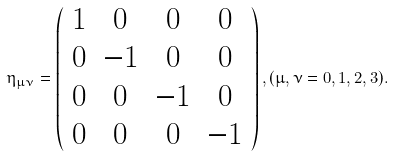Convert formula to latex. <formula><loc_0><loc_0><loc_500><loc_500>\eta _ { \mu \nu } = \left ( \begin{array} { c c c c } 1 & 0 & 0 & 0 \\ 0 & - 1 & 0 & 0 \\ 0 & 0 & - 1 & 0 \\ 0 & 0 & 0 & - 1 \end{array} \right ) , ( \mu , \nu = 0 , 1 , 2 , 3 ) .</formula> 